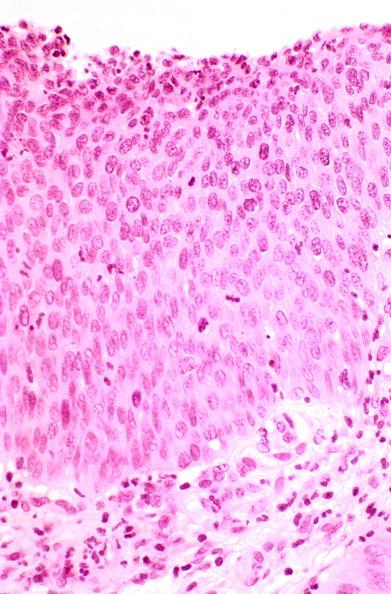s thecoma present?
Answer the question using a single word or phrase. No 